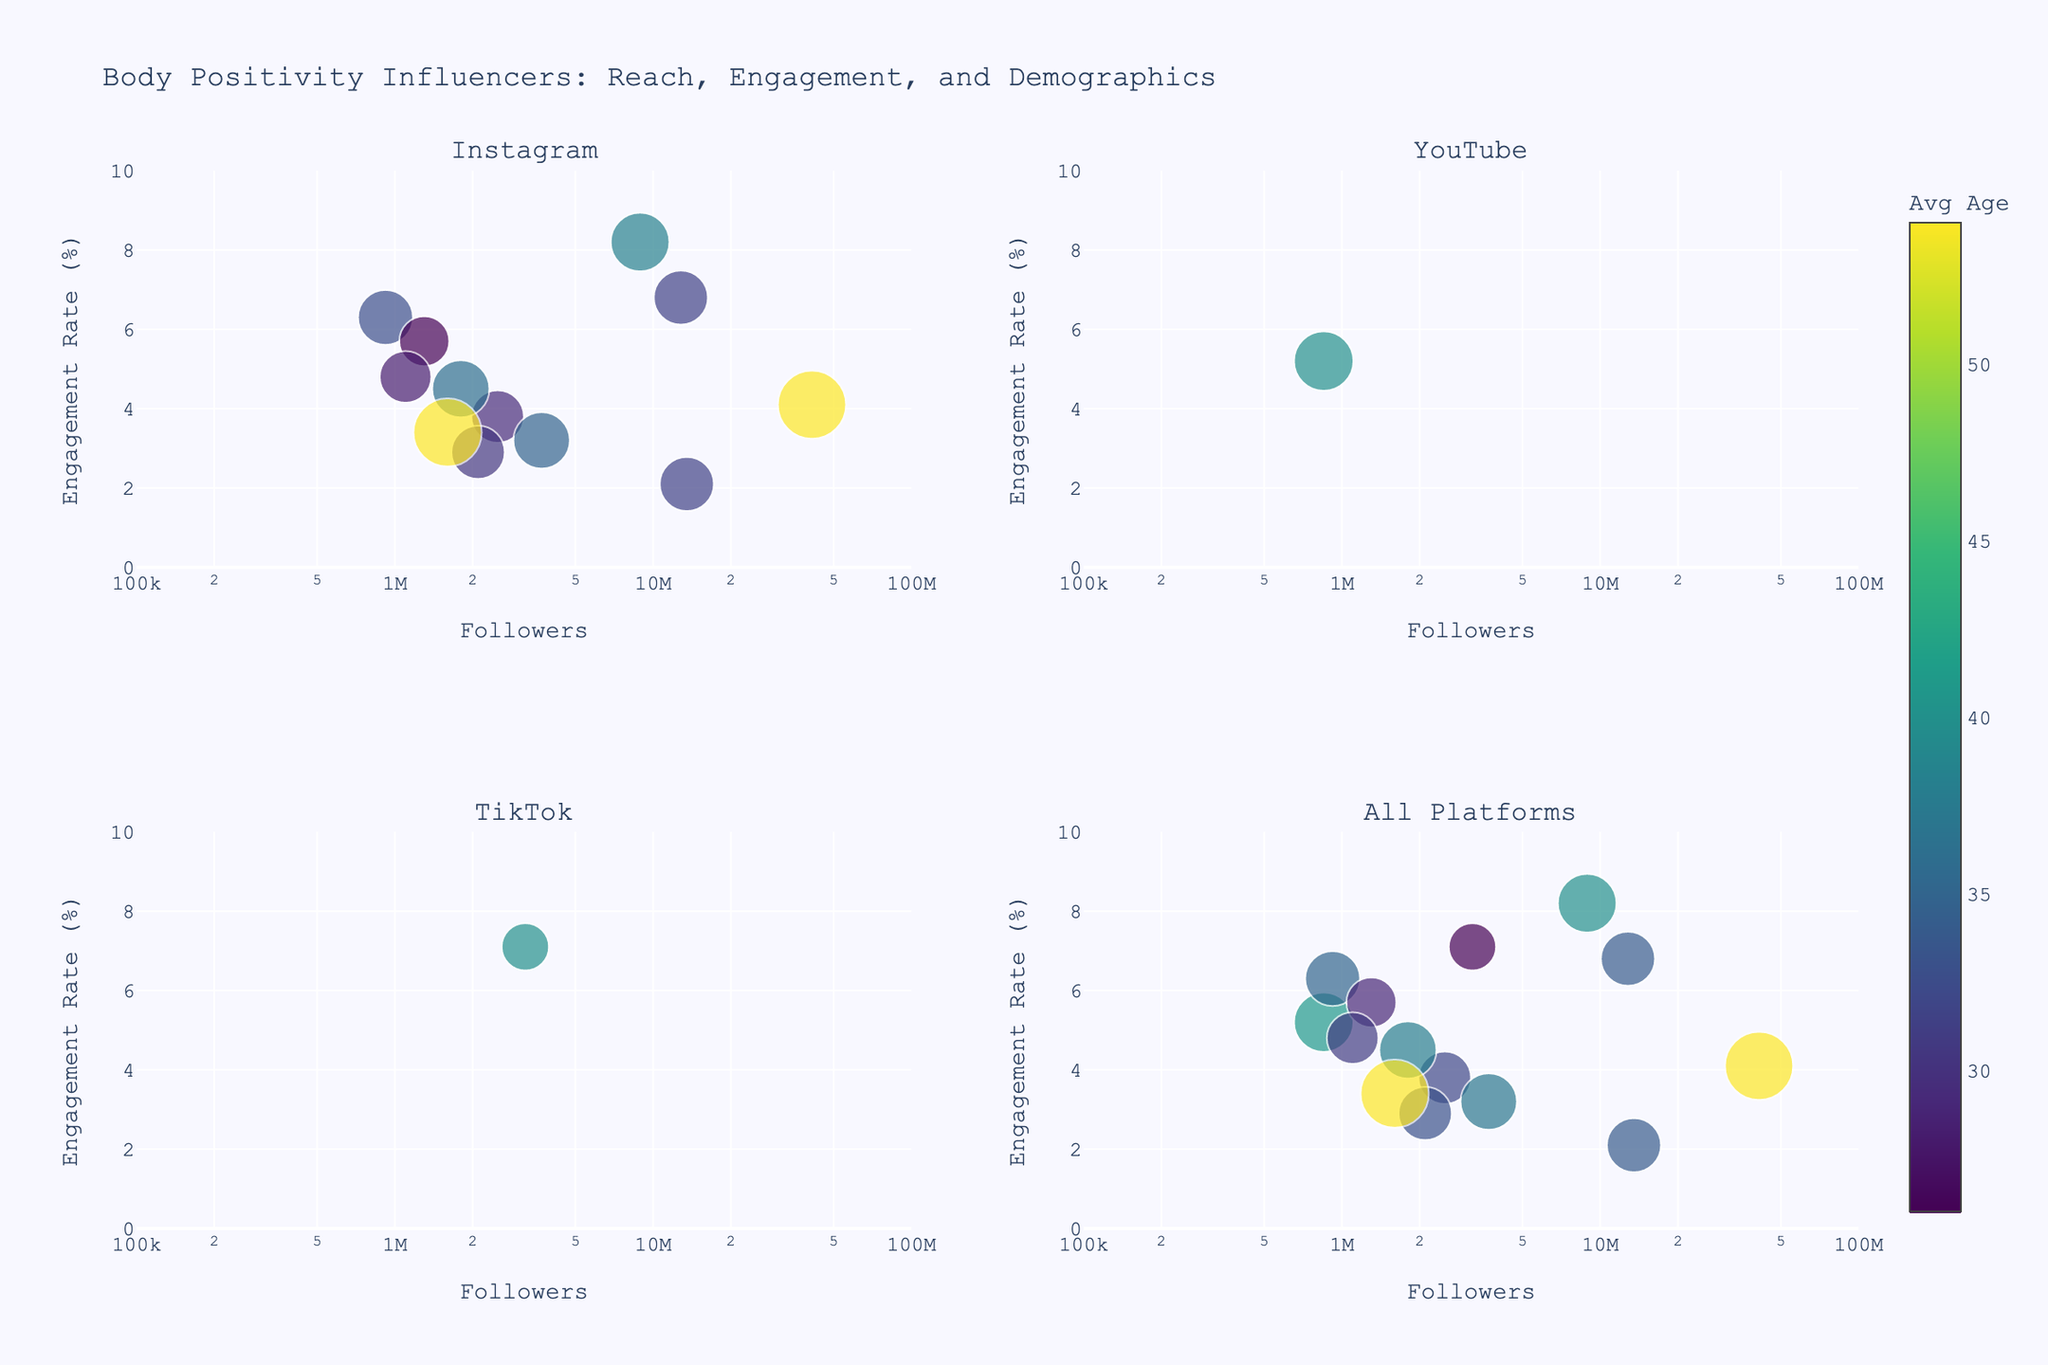How many influencers are shown in the Instagram subplot? By counting the bubbles in the Instagram subplot, we find there are 10 influencers represented.
Answer: 10 Which influencer has the highest engagement rate on TikTok? There is only one influencer on TikTok in the subplot, so we check their engagement rate. Sarah Samdahl has an engagement rate of 7.1%.
Answer: Sarah Samdahl Who is the influencer with the most followers on Instagram? By observing the Instagram subplot, we see the largest bubble in terms of followers is for Jennifer Aniston with 41,200,000 followers.
Answer: Jennifer Aniston What is the average age of influencers on YouTube? The YouTube subplot has data for only one influencer: Meg Bodytecture, who has an age of 41. So, the average age is 41.
Answer: 41 Which influencer on Instagram has the lowest engagement rate? By examining the Instagram subplot, the influencer with the smallest position on the y-axis is Ashley Graham with an engagement rate of 2.1%.
Answer: Ashley Graham Compare the engagement rates of Celeste Barber and Lizzo on Instagram. Who has a higher rate? We locate Celeste Barber and Lizzo in the Instagram subplot. Celeste Barber has an engagement rate of 8.2%, while Lizzo has 6.8%. Comparatively, Celeste Barber's engagement rate is higher.
Answer: Celeste Barber What is the range of the x-axis in the subplot for all platforms? The x-axis range on the plot for all platforms spans followers, which is specified in the plot code as [5, 8] on a logarithmic scale.
Answer: 5 to 8 (logarithmic scale) Identify the influencers aged 34 on Instagram. By examining the colors of the bubbles (corresponding to average age) in the Instagram subplot and matching ages, we find Ashley Graham and Lizzo are both aged 34.
Answer: Ashley Graham, Lizzo What is the overall trend between the number of followers and engagement rate across all platforms? By viewing the subplot for all platforms, we notice that there does not appear to be a consistent trend. Some influencers with fewer followers have high engagement rates, while others with more followers have lower engagement rates.
Answer: No consistent trend 